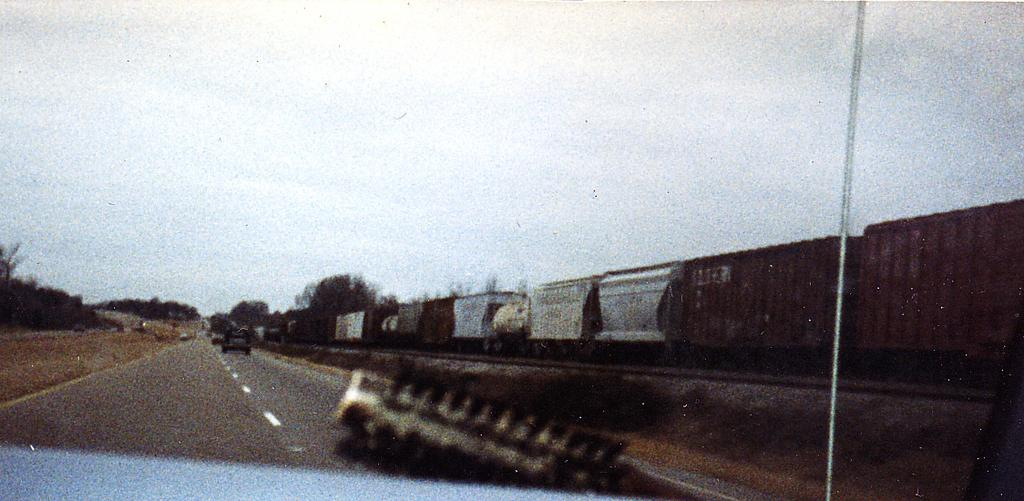What is the main subject of the image? There is a train in the image. Where is the train located in the image? The train is on the right side of the image. What is next to the train in the image? There is a road beside the train. What is on the road in the image? There are vehicles on the road. What can be seen around the road in the image? There are many trees around the road. What type of pain is the train experiencing in the image? There is no indication of pain in the image; the train is a non-living object and cannot experience pain. 